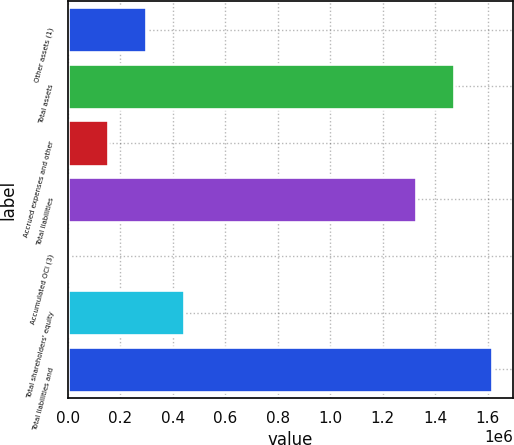Convert chart. <chart><loc_0><loc_0><loc_500><loc_500><bar_chart><fcel>Other assets (1)<fcel>Total assets<fcel>Accrued expenses and other<fcel>Total liabilities<fcel>Accumulated OCI (3)<fcel>Total shareholders' equity<fcel>Total liabilities and<nl><fcel>297463<fcel>1.47065e+06<fcel>151933<fcel>1.32512e+06<fcel>6403<fcel>442993<fcel>1.61618e+06<nl></chart> 